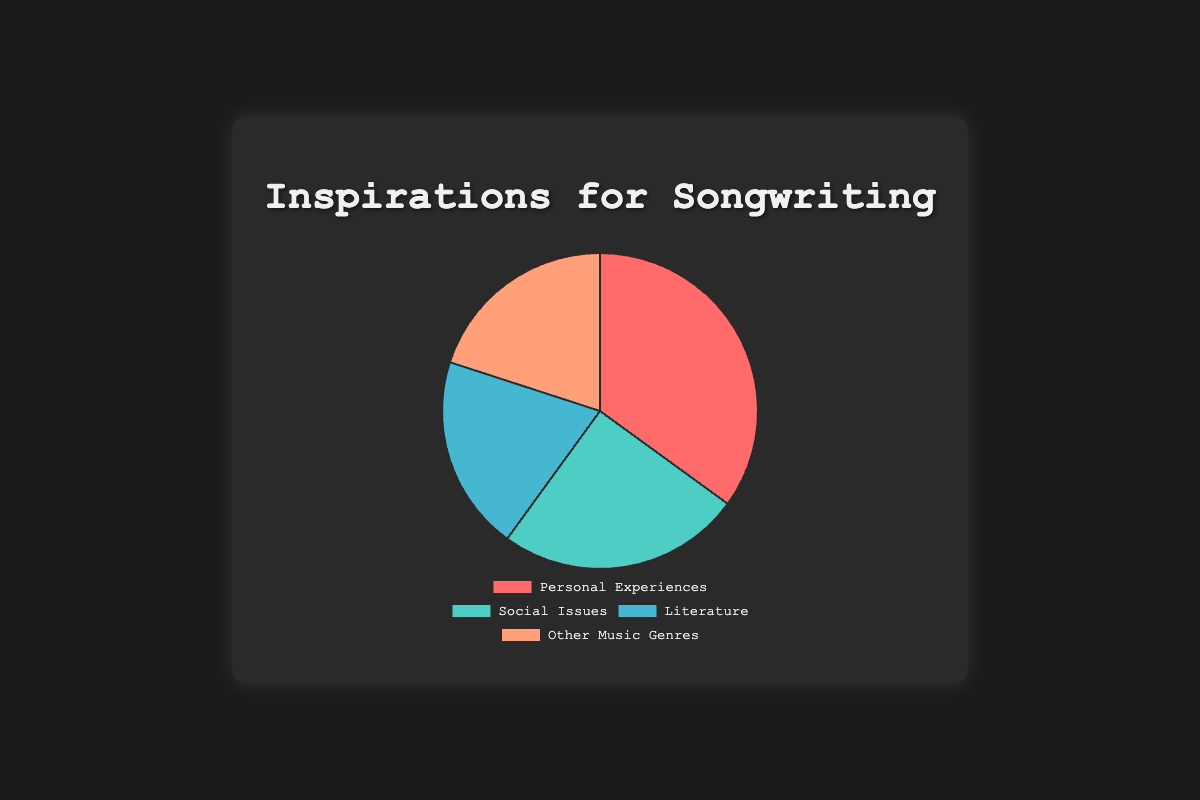What's the largest source of inspiration in the chart? Looking at the pie chart, we see that "Personal Experiences" has the highest percentage, 35%, compared to other categories.
Answer: Personal Experiences Which sources of inspiration have equal contributions? The pie chart shows that both "Literature" and "Other Music Genres" have the same contribution, each with 20%.
Answer: Literature and Other Music Genres What is the total percentage of inspirations derived from external sources (Social Issues, Literature, and Other Music Genres)? Sum the percentages of "Social Issues" (25%), "Literature" (20%), and "Other Music Genres" (20%); 25% + 20% + 20% equals 65%.
Answer: 65% Which category's inspiration comes second in terms of contribution? The next highest percentage after "Personal Experiences" (35%) is "Social Issues" (25%).
Answer: Social Issues How much more significant are Personal Experiences compared to Literature? Subtract the percentage of "Literature" (20%) from "Personal Experiences" (35%); 35% - 20% equals 15%.
Answer: 15% What color represents the Social Issues category? The pie chart assigns a specific color to each category; "Social Issues" corresponds to a blue-green color.
Answer: blue-green Is the sum of Literature and Other Music Genres greater than Personal Experiences? Sum the percentages of "Literature" (20%) and "Other Music Genres" (20%); 20% + 20% equals 40%, which is greater than "Personal Experiences" at 35%.
Answer: Yes What percentage is allocated to the least significant categories combined? The least significant categories are "Literature" and "Other Music Genres" (both with 20%). Sum those percentages; 20% + 20% equals 40%.
Answer: 40% Which color marks the Personal Experiences category? The chart shows that "Personal Experiences" is marked in a red color.
Answer: red 